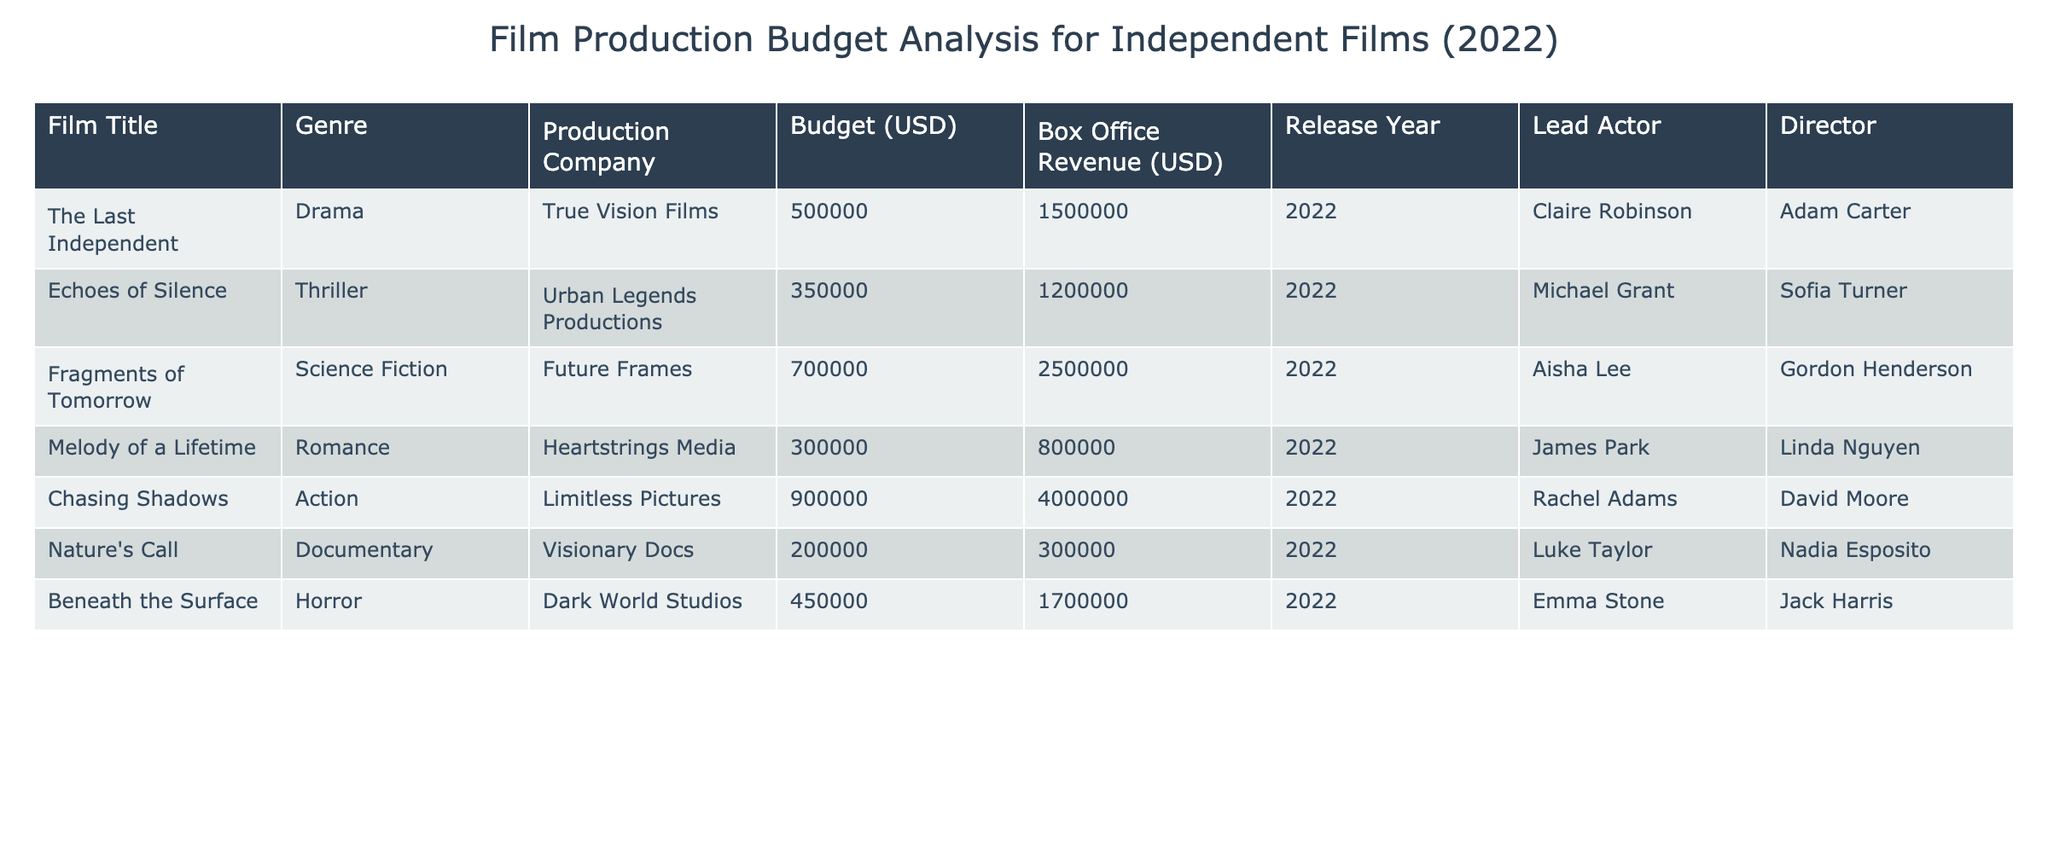What is the budget for "Chasing Shadows"? The budget for "Chasing Shadows," as indicated in the table, is directly listed under the Budget column. It shows a value of 900000.
Answer: 900000 Which film has the highest box office revenue? By comparing the Box Office Revenue column, "Chasing Shadows" has the highest value at 4000000.
Answer: Chasing Shadows What is the average budget of all the films? To find the average, add all the budgets (500000 + 350000 + 700000 + 300000 + 900000 + 200000 + 450000) which equals 3100000. Then, divide by the number of films (7), giving an average of 442857.14.
Answer: 442857.14 Is "Echoes of Silence" a documentary film? Looking under the Genre column, "Echoes of Silence" is categorized as a Thriller, which confirms it is not a documentary.
Answer: No What is the total box office revenue for all the films in the table? To find the total box office revenues, we sum each film's revenue: (1500000 + 1200000 + 2500000 + 800000 + 4000000 + 300000 + 1700000) which totals 10700000.
Answer: 10700000 Which film has the lowest budget and what is its lead actor? The lowest budget listed is for "Nature's Call" at 200000. Its lead actor, as shown in the Lead Actor column, is Luke Taylor.
Answer: Nature's Call, Luke Taylor What percentage of the budget did "Fragments of Tomorrow" make in box office revenue? First, calculate the revenue percentage by dividing the box office by the budget: (2500000 / 700000) * 100, which results in approximately 357.14%.
Answer: 357.14% Which genre had the film with the highest budget? By reviewing the Budget column, "Chasing Shadows" is the film with the highest budget of 900000, categorized under Action. Thus, Action is the genre related to the highest budget.
Answer: Action 